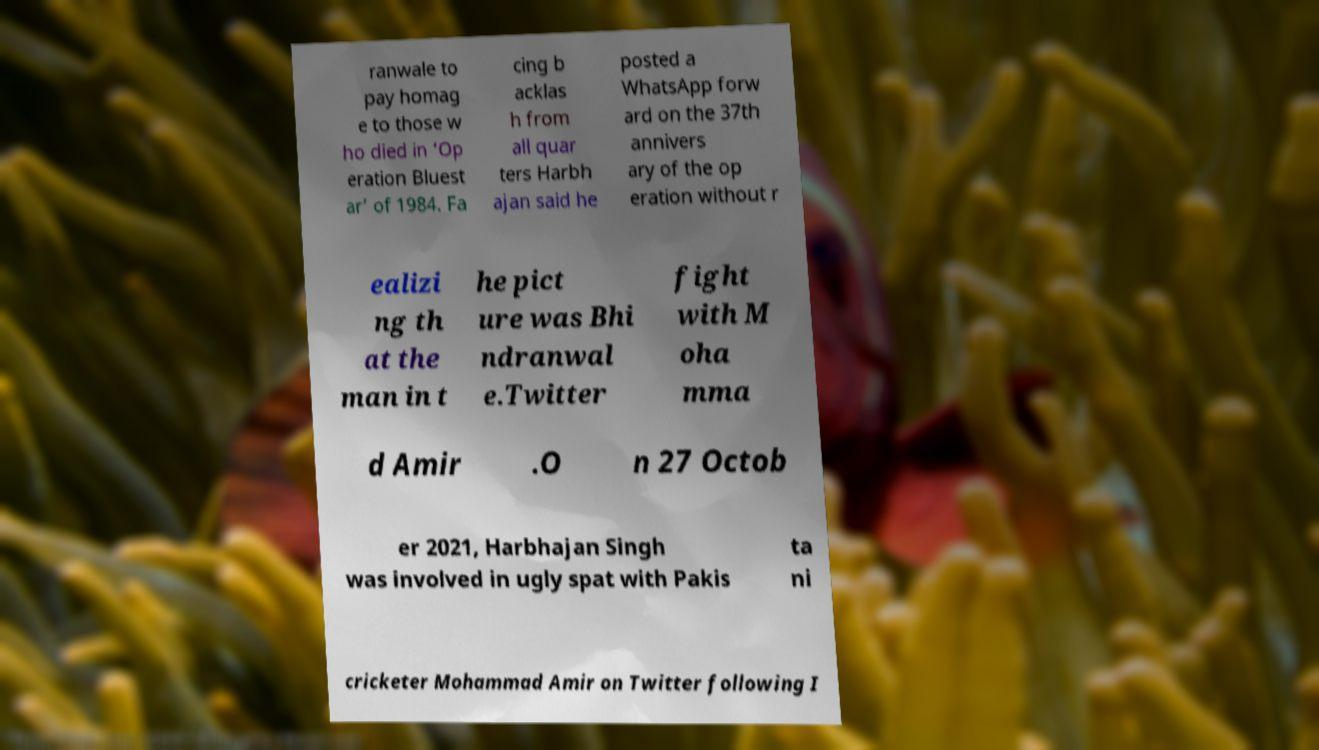For documentation purposes, I need the text within this image transcribed. Could you provide that? ranwale to pay homag e to those w ho died in ‘Op eration Bluest ar’ of 1984. Fa cing b acklas h from all quar ters Harbh ajan said he posted a WhatsApp forw ard on the 37th annivers ary of the op eration without r ealizi ng th at the man in t he pict ure was Bhi ndranwal e.Twitter fight with M oha mma d Amir .O n 27 Octob er 2021, Harbhajan Singh was involved in ugly spat with Pakis ta ni cricketer Mohammad Amir on Twitter following I 